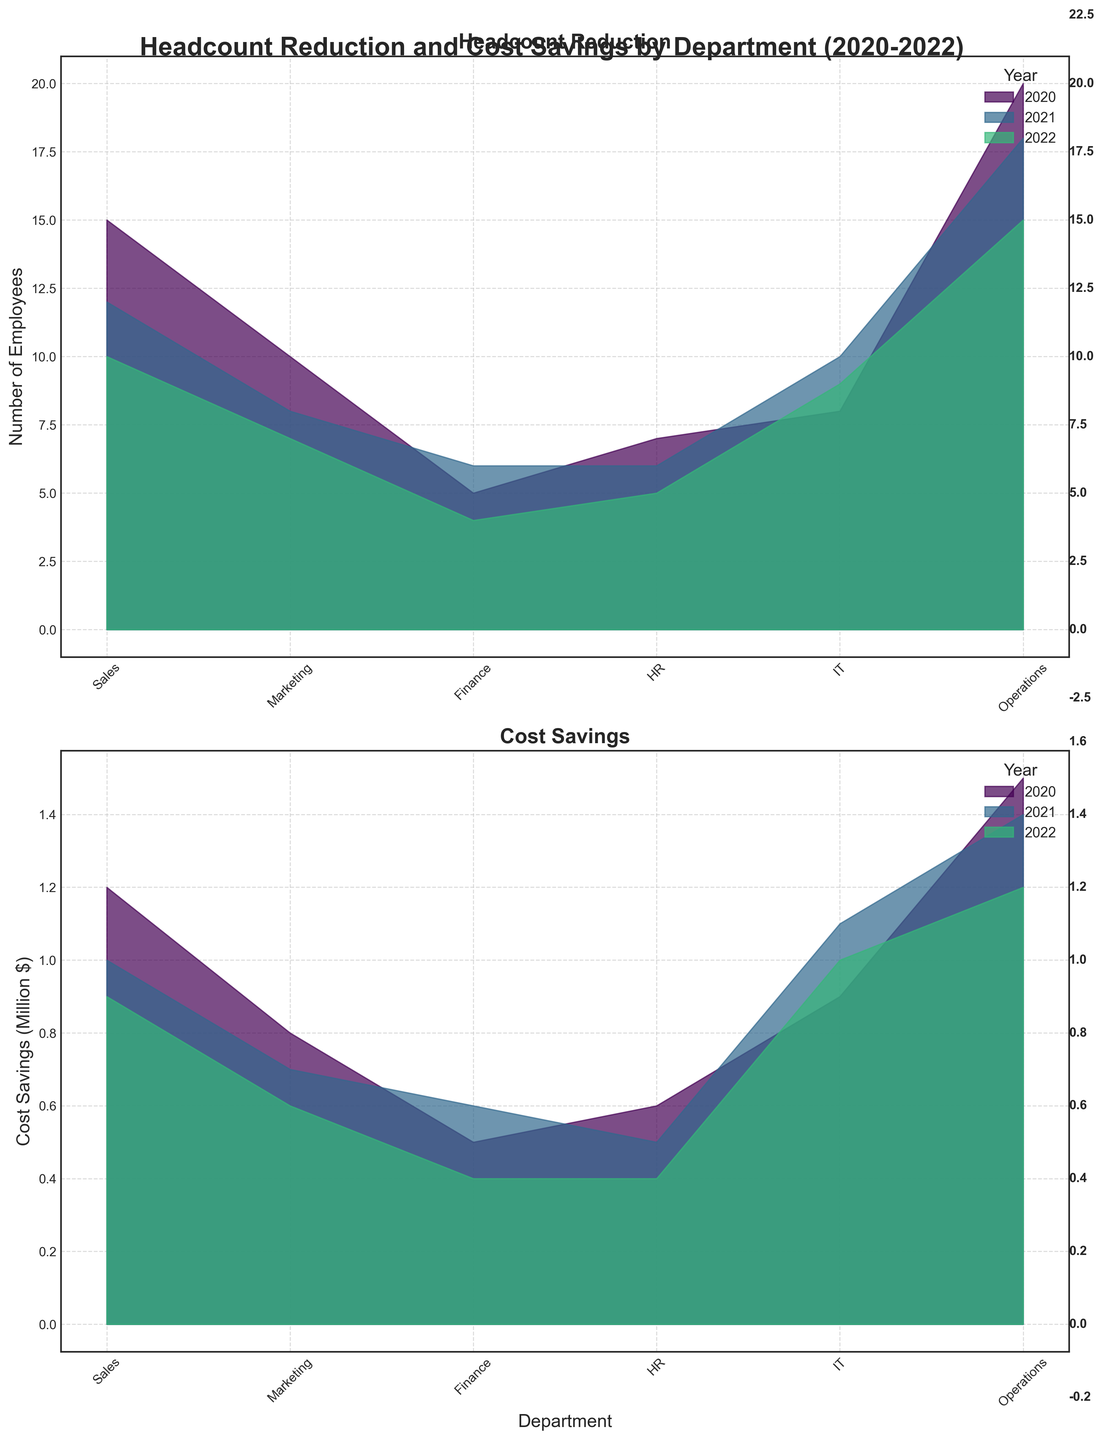What's the title of the plot? The title of the plot is positioned at the top center of the figure. It's written in bold and large font.
Answer: Headcount Reduction and Cost Savings by Department (2020-2022) How many departments are shown in the plot? The x-axis of the area charts shows the departments, and there are labels for each one. Counting these labels gives the number of departments.
Answer: 6 In which year did the 'IT' department have the highest cost savings? Examine the 'Cost Savings' subplot and look at the area corresponding to the 'IT' department across different years. The highest fill area indicates the year with the highest cost savings.
Answer: 2021 What was the total cost saved by the 'Sales' department in 2021 and 2022 combined? Add the cost savings in the 'Sales' department for the years 2021 and 2022.
Answer: 1.9 million $ Which department showed the least variation in cost savings over the three years? Evaluate the cost savings subplot for the department with the most uniformly filled areas across the three years. Check the range to see the smallest variation.
Answer: Finance Comparing 'Sales' and 'Marketing', which department had higher headcount reductions in 2020? Look at the headcount reductions in the 'Headcount Reduction' subplot for both departments in the year 2020 for comparison.
Answer: Sales 